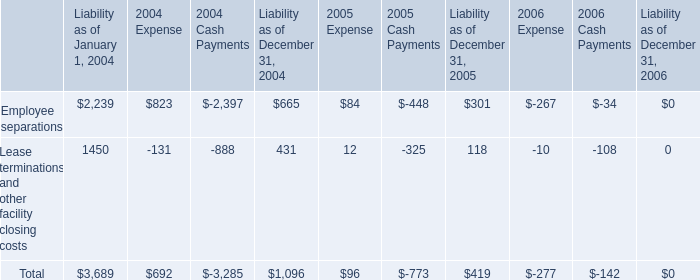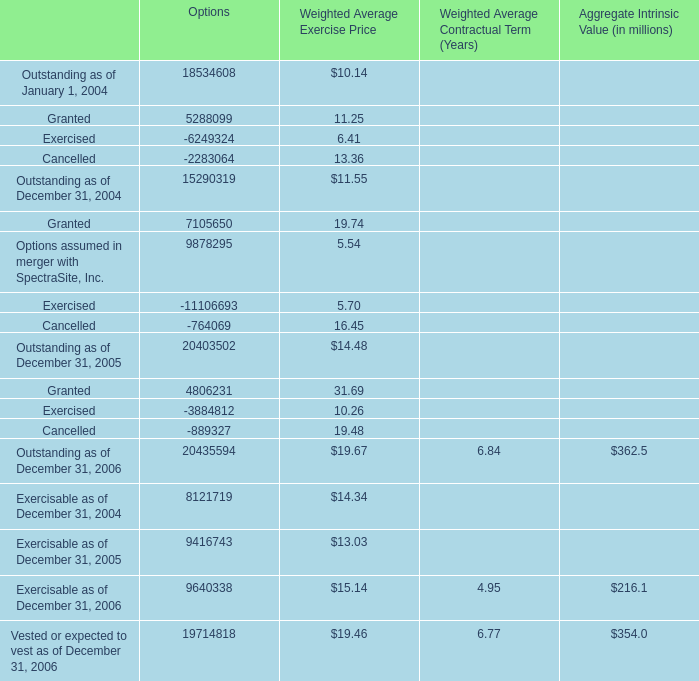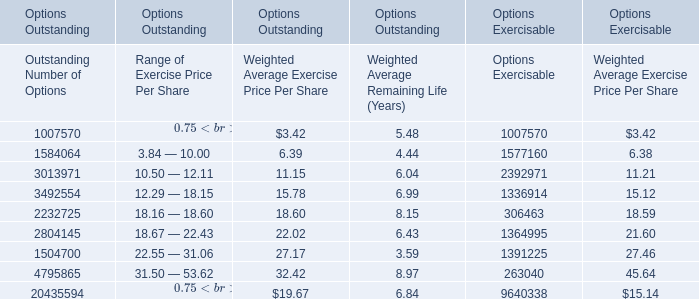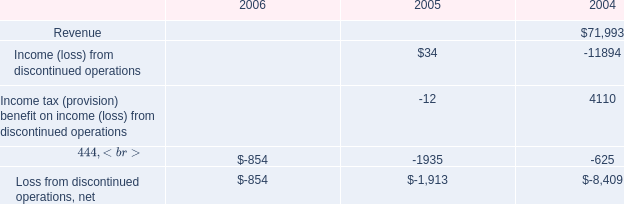What's the average of Loss from discontinued operations, net of 2005, and Exercisable as of December 31, 2005 of Options ? 
Computations: ((1913.0 + 9416743.0) / 2)
Answer: 4709328.0. 